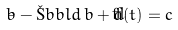Convert formula to latex. <formula><loc_0><loc_0><loc_500><loc_500>\dot { b } - \L b b l d \, b + \breve { a } ( t ) = c</formula> 